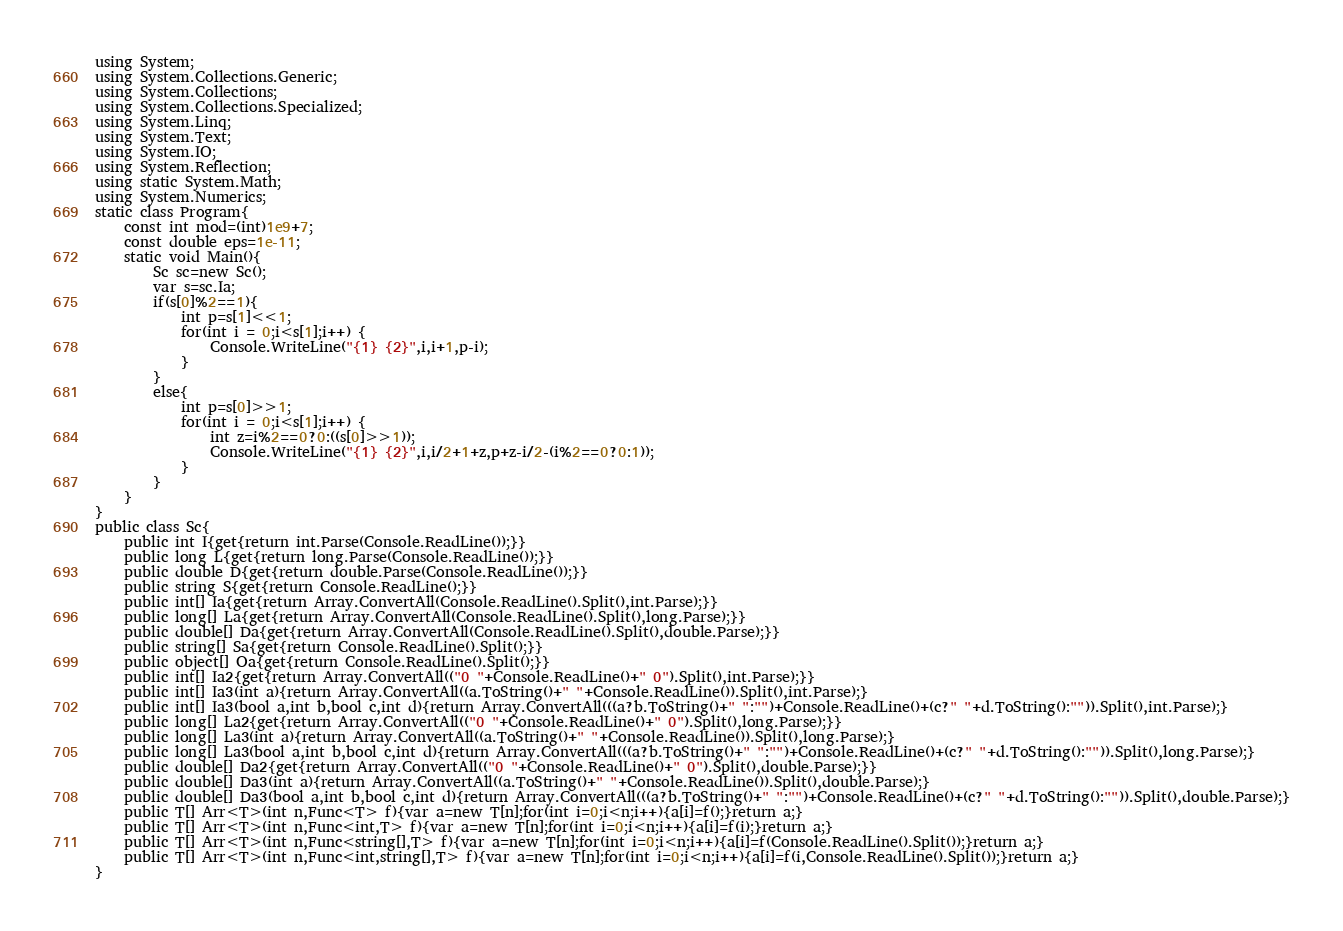Convert code to text. <code><loc_0><loc_0><loc_500><loc_500><_C#_>using System;
using System.Collections.Generic;
using System.Collections;
using System.Collections.Specialized;
using System.Linq;
using System.Text;
using System.IO;
using System.Reflection;
using static System.Math;
using System.Numerics;
static class Program{
	const int mod=(int)1e9+7;
	const double eps=1e-11;
	static void Main(){
		Sc sc=new Sc();
		var s=sc.Ia;
		if(s[0]%2==1){
			int p=s[1]<<1;
			for(int i = 0;i<s[1];i++) {
				Console.WriteLine("{1} {2}",i,i+1,p-i);
			}
		}
		else{
			int p=s[0]>>1;
			for(int i = 0;i<s[1];i++) {
				int z=i%2==0?0:((s[0]>>1));
				Console.WriteLine("{1} {2}",i,i/2+1+z,p+z-i/2-(i%2==0?0:1));
			}
		}
	}
}
public class Sc{
	public int I{get{return int.Parse(Console.ReadLine());}}
	public long L{get{return long.Parse(Console.ReadLine());}}
	public double D{get{return double.Parse(Console.ReadLine());}}
	public string S{get{return Console.ReadLine();}}
	public int[] Ia{get{return Array.ConvertAll(Console.ReadLine().Split(),int.Parse);}}
	public long[] La{get{return Array.ConvertAll(Console.ReadLine().Split(),long.Parse);}}
	public double[] Da{get{return Array.ConvertAll(Console.ReadLine().Split(),double.Parse);}}
	public string[] Sa{get{return Console.ReadLine().Split();}}
	public object[] Oa{get{return Console.ReadLine().Split();}}
	public int[] Ia2{get{return Array.ConvertAll(("0 "+Console.ReadLine()+" 0").Split(),int.Parse);}}
	public int[] Ia3(int a){return Array.ConvertAll((a.ToString()+" "+Console.ReadLine()).Split(),int.Parse);}
	public int[] Ia3(bool a,int b,bool c,int d){return Array.ConvertAll(((a?b.ToString()+" ":"")+Console.ReadLine()+(c?" "+d.ToString():"")).Split(),int.Parse);}
	public long[] La2{get{return Array.ConvertAll(("0 "+Console.ReadLine()+" 0").Split(),long.Parse);}}
	public long[] La3(int a){return Array.ConvertAll((a.ToString()+" "+Console.ReadLine()).Split(),long.Parse);}
	public long[] La3(bool a,int b,bool c,int d){return Array.ConvertAll(((a?b.ToString()+" ":"")+Console.ReadLine()+(c?" "+d.ToString():"")).Split(),long.Parse);}
	public double[] Da2{get{return Array.ConvertAll(("0 "+Console.ReadLine()+" 0").Split(),double.Parse);}}
	public double[] Da3(int a){return Array.ConvertAll((a.ToString()+" "+Console.ReadLine()).Split(),double.Parse);}
	public double[] Da3(bool a,int b,bool c,int d){return Array.ConvertAll(((a?b.ToString()+" ":"")+Console.ReadLine()+(c?" "+d.ToString():"")).Split(),double.Parse);}
	public T[] Arr<T>(int n,Func<T> f){var a=new T[n];for(int i=0;i<n;i++){a[i]=f();}return a;}
	public T[] Arr<T>(int n,Func<int,T> f){var a=new T[n];for(int i=0;i<n;i++){a[i]=f(i);}return a;}
	public T[] Arr<T>(int n,Func<string[],T> f){var a=new T[n];for(int i=0;i<n;i++){a[i]=f(Console.ReadLine().Split());}return a;}
	public T[] Arr<T>(int n,Func<int,string[],T> f){var a=new T[n];for(int i=0;i<n;i++){a[i]=f(i,Console.ReadLine().Split());}return a;}
}</code> 